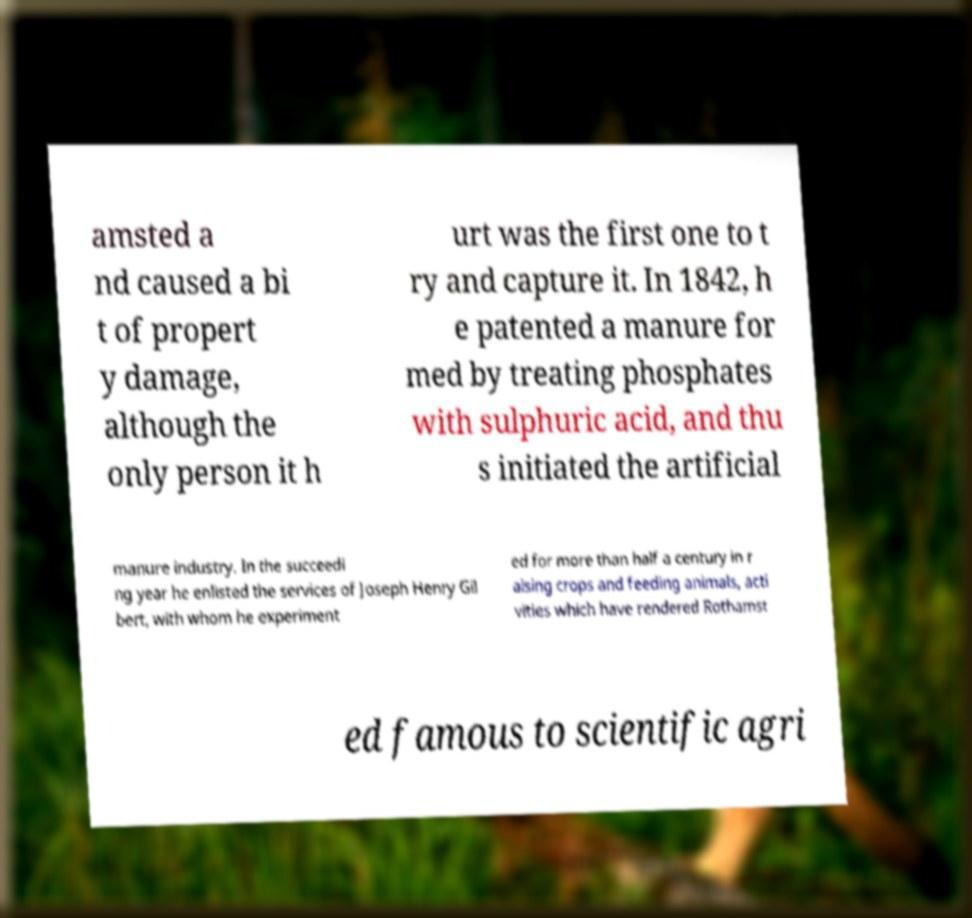What messages or text are displayed in this image? I need them in a readable, typed format. amsted a nd caused a bi t of propert y damage, although the only person it h urt was the first one to t ry and capture it. In 1842, h e patented a manure for med by treating phosphates with sulphuric acid, and thu s initiated the artificial manure industry. In the succeedi ng year he enlisted the services of Joseph Henry Gil bert, with whom he experiment ed for more than half a century in r aising crops and feeding animals, acti vities which have rendered Rothamst ed famous to scientific agri 